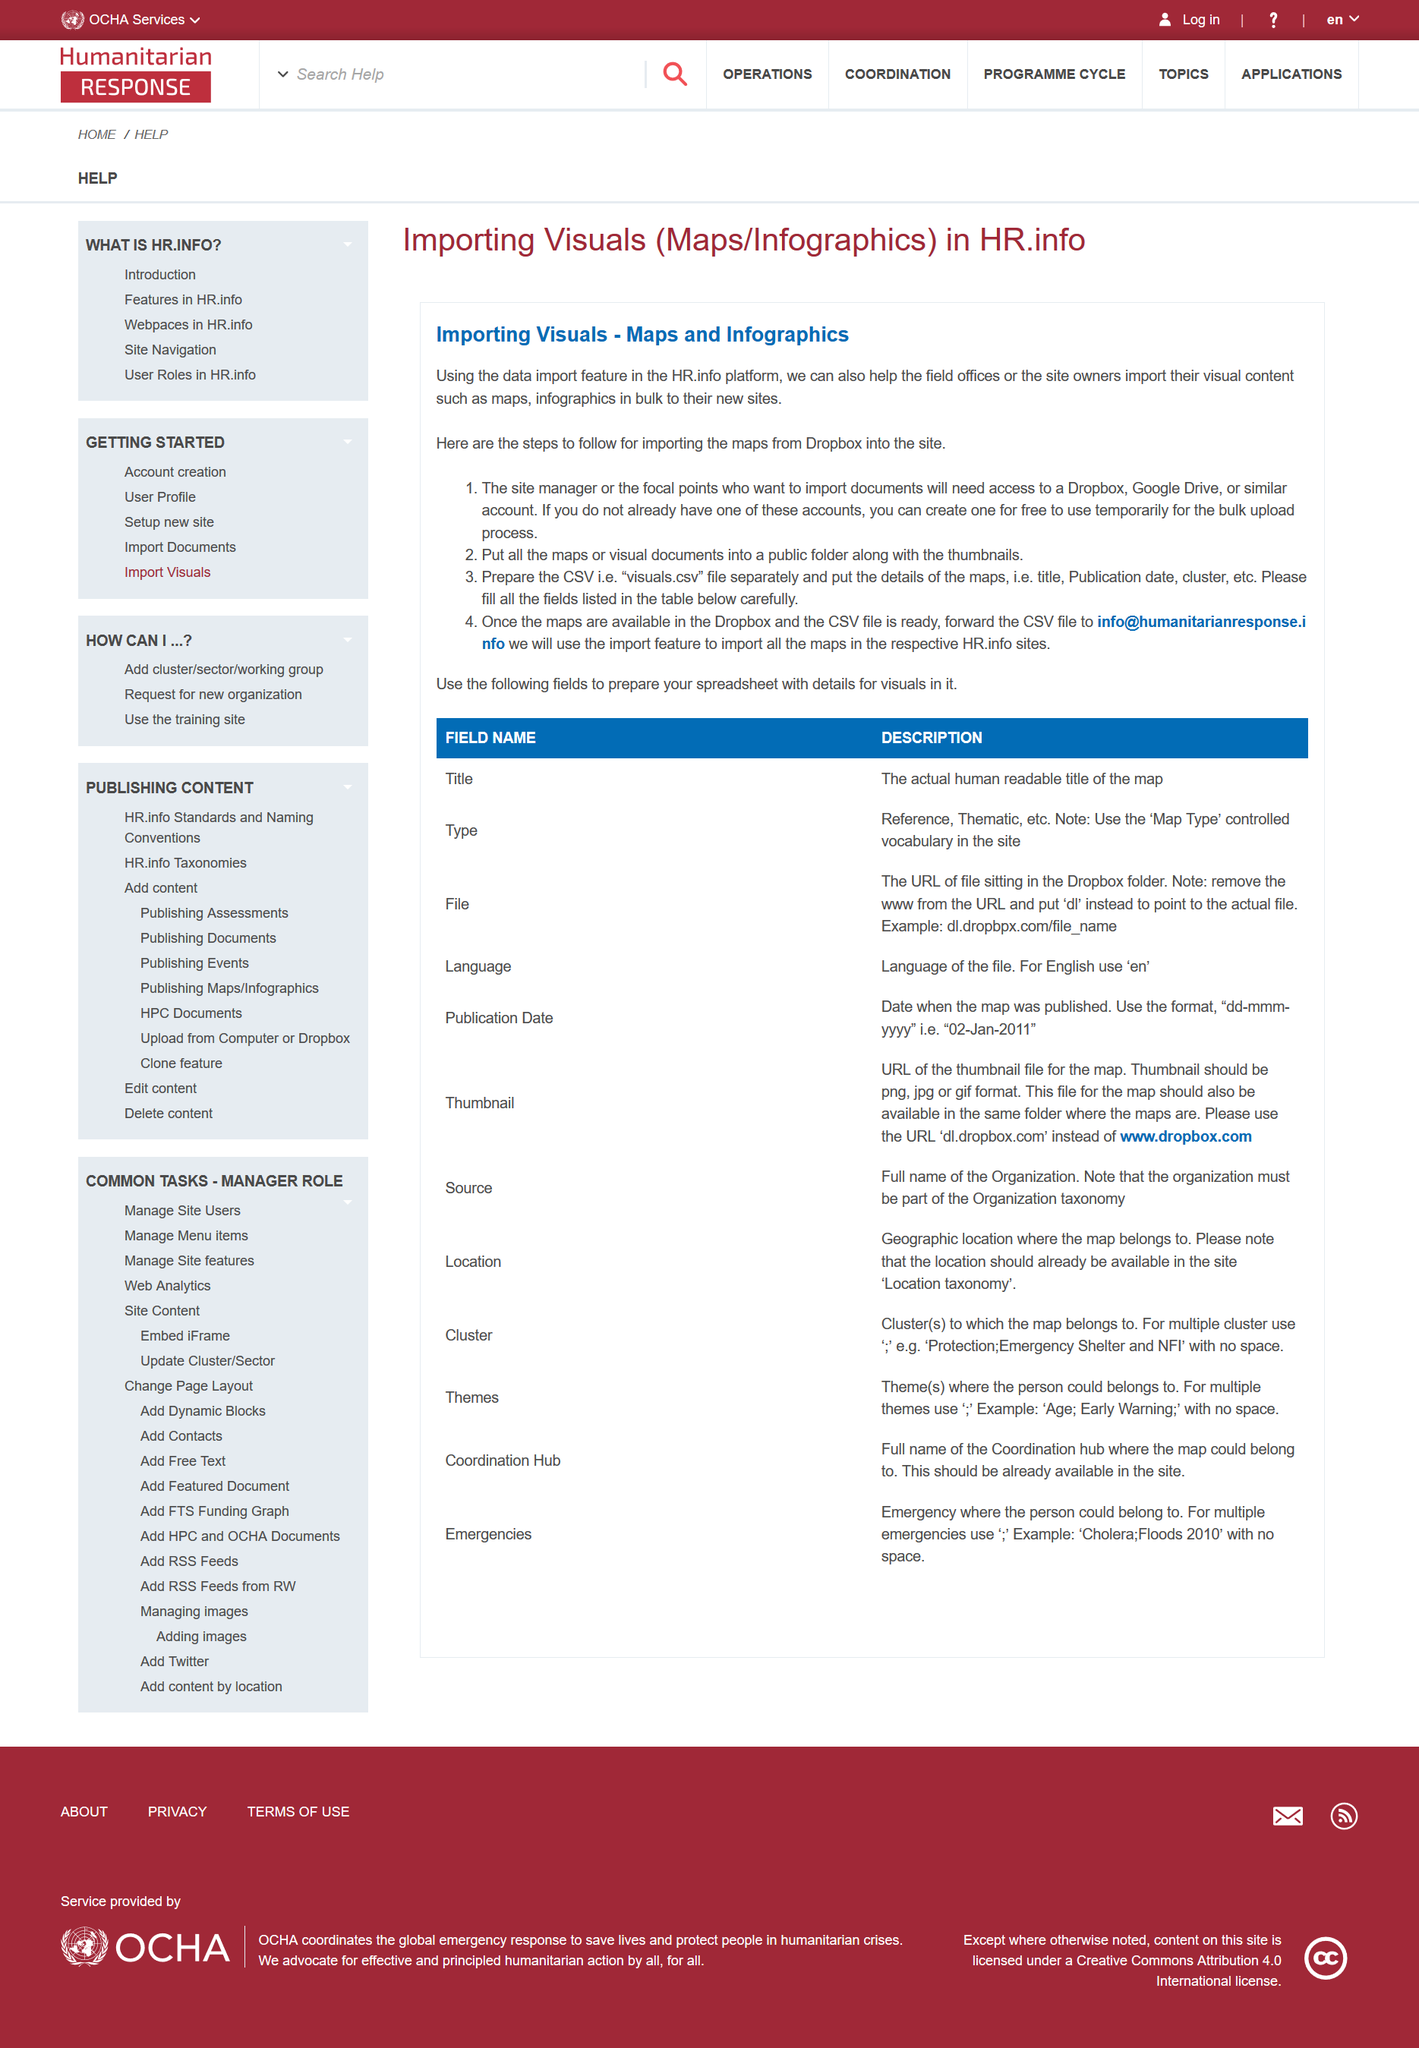Indicate a few pertinent items in this graphic. In step one, the site manager will need to have access to two specific accounts: Dropbox and Google Drive. In step two, the maps should be placed in a public folder, along with the thumbnails. There are four steps involved in importing maps from Dropbox into the site. 